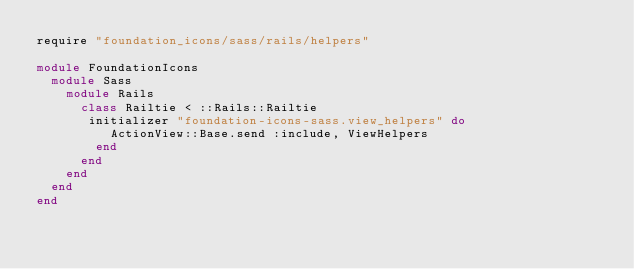Convert code to text. <code><loc_0><loc_0><loc_500><loc_500><_Ruby_>require "foundation_icons/sass/rails/helpers"

module FoundationIcons
  module Sass
    module Rails
      class Railtie < ::Rails::Railtie
       initializer "foundation-icons-sass.view_helpers" do
          ActionView::Base.send :include, ViewHelpers
        end
      end
    end
  end
end</code> 